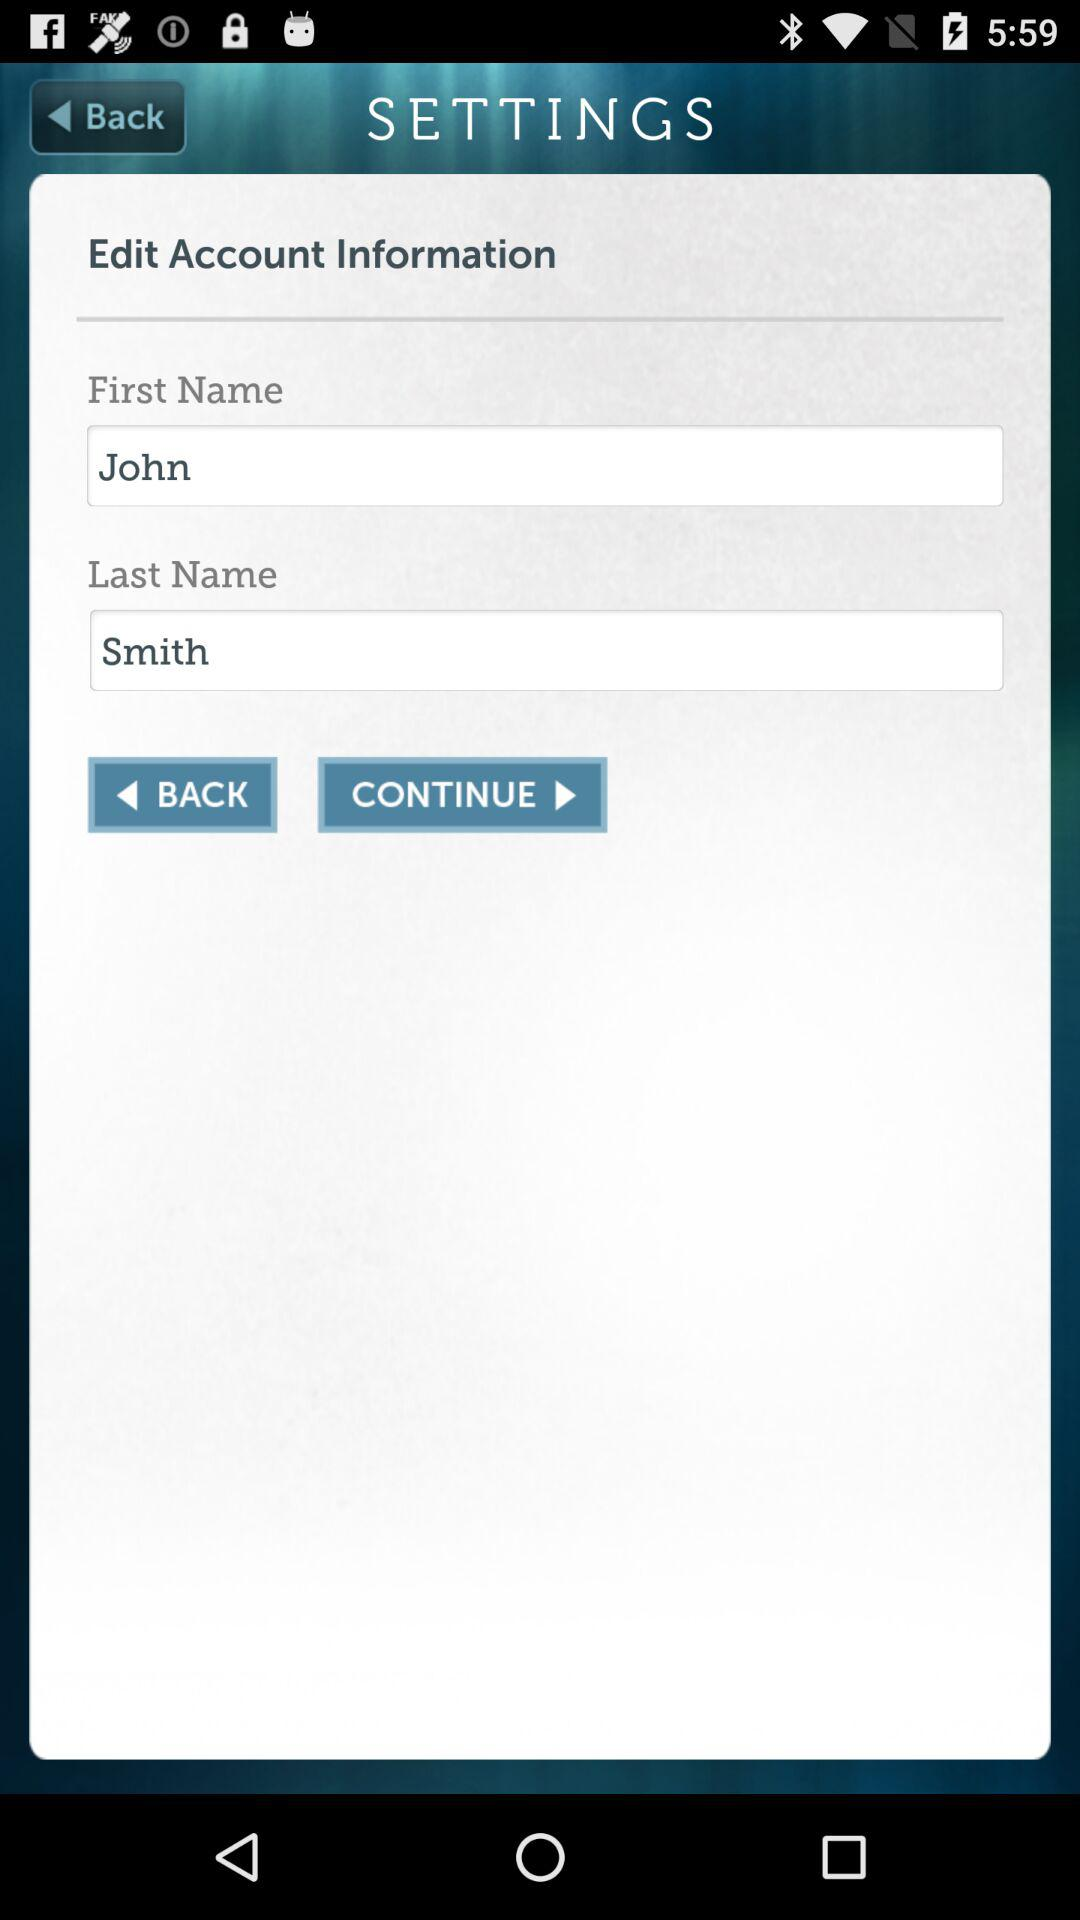How many fields are there in the account information form?
Answer the question using a single word or phrase. 2 